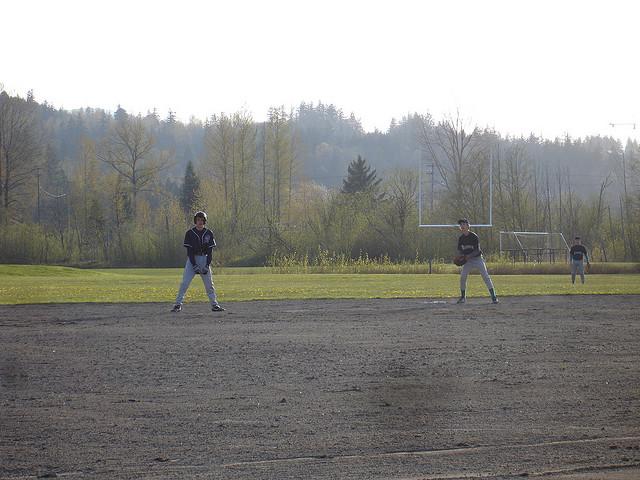Is the umpire in the photo?
Quick response, please. No. What are the boys doing?
Short answer required. Playing baseball. What is in the horizon?
Keep it brief. Trees. What sport are they playing?
Write a very short answer. Baseball. 